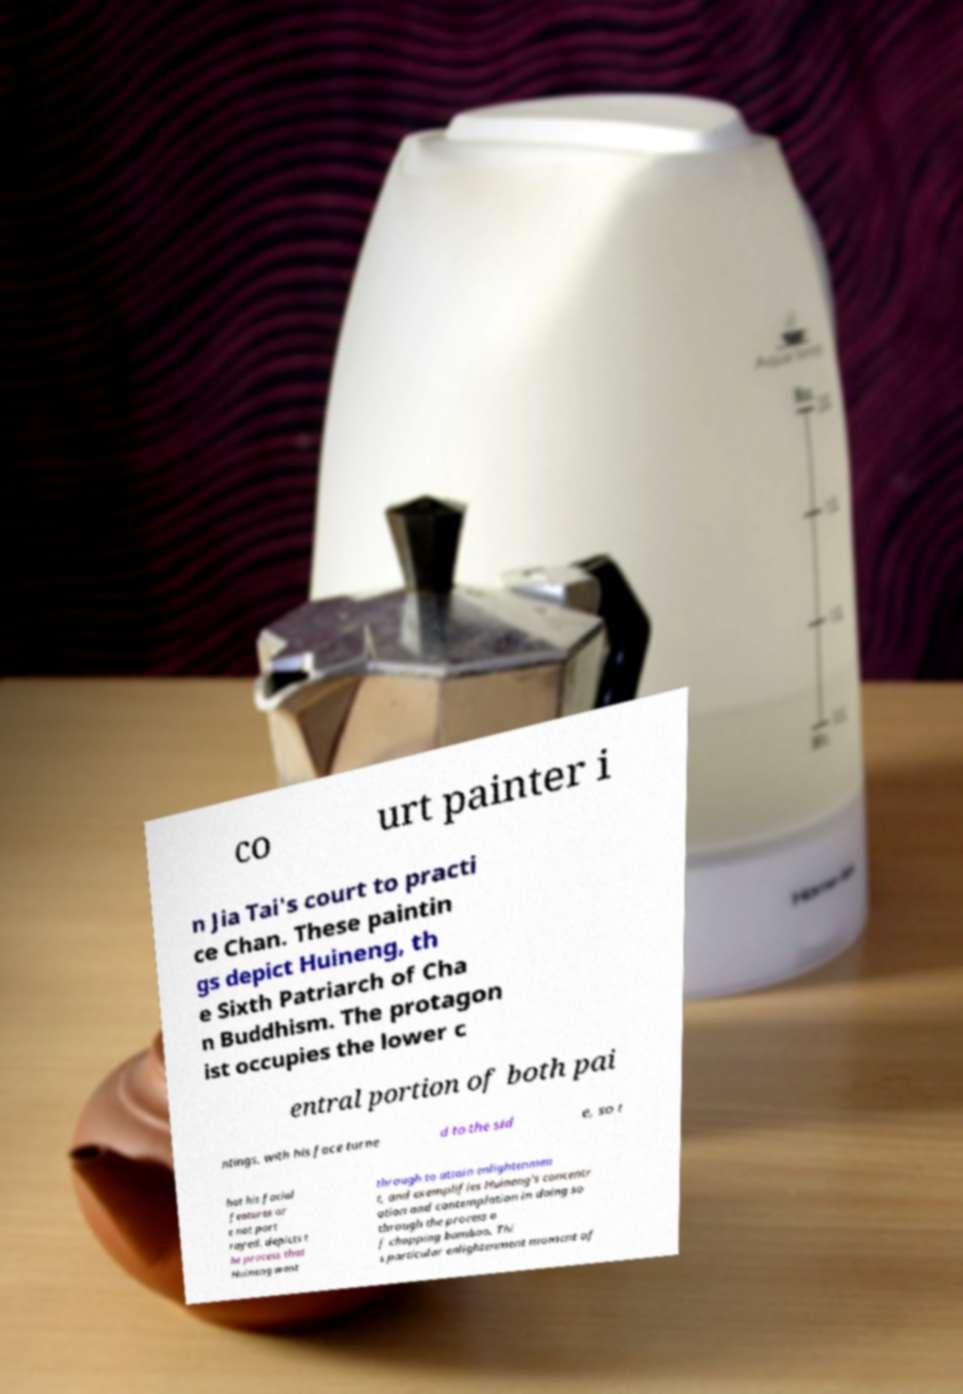Could you extract and type out the text from this image? co urt painter i n Jia Tai's court to practi ce Chan. These paintin gs depict Huineng, th e Sixth Patriarch of Cha n Buddhism. The protagon ist occupies the lower c entral portion of both pai ntings, with his face turne d to the sid e, so t hat his facial features ar e not port rayed. depicts t he process that Huineng went through to attain enlightenmen t, and exemplifies Huineng's concentr ation and contemplation in doing so through the process o f chopping bamboo. Thi s particular enlightenment moment of 